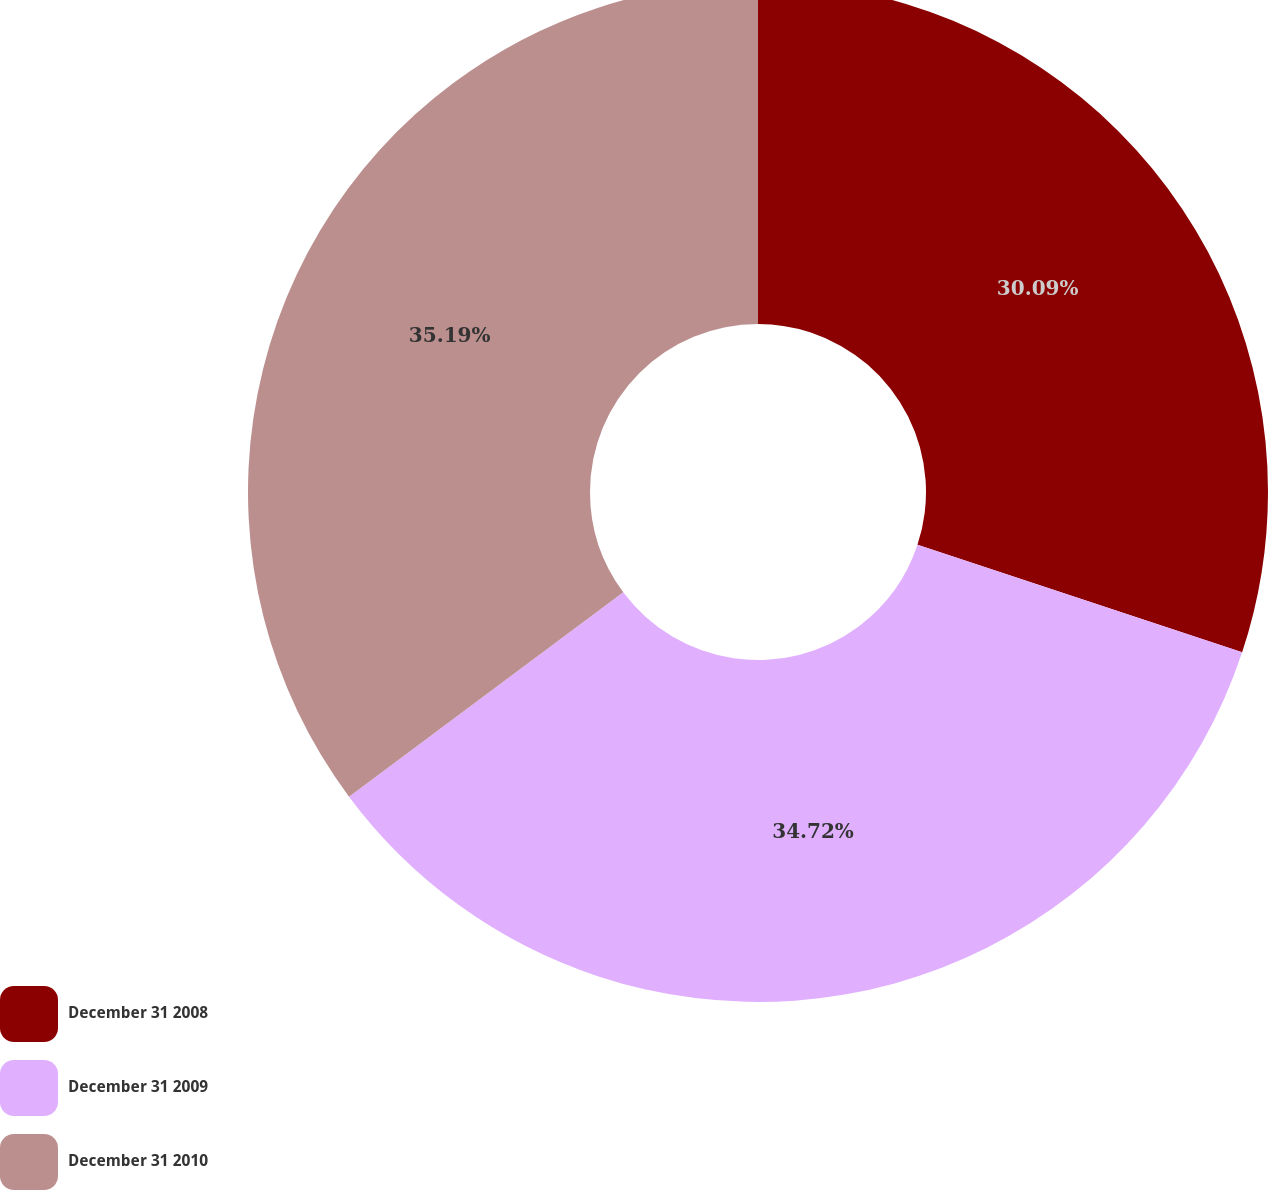Convert chart to OTSL. <chart><loc_0><loc_0><loc_500><loc_500><pie_chart><fcel>December 31 2008<fcel>December 31 2009<fcel>December 31 2010<nl><fcel>30.09%<fcel>34.72%<fcel>35.19%<nl></chart> 